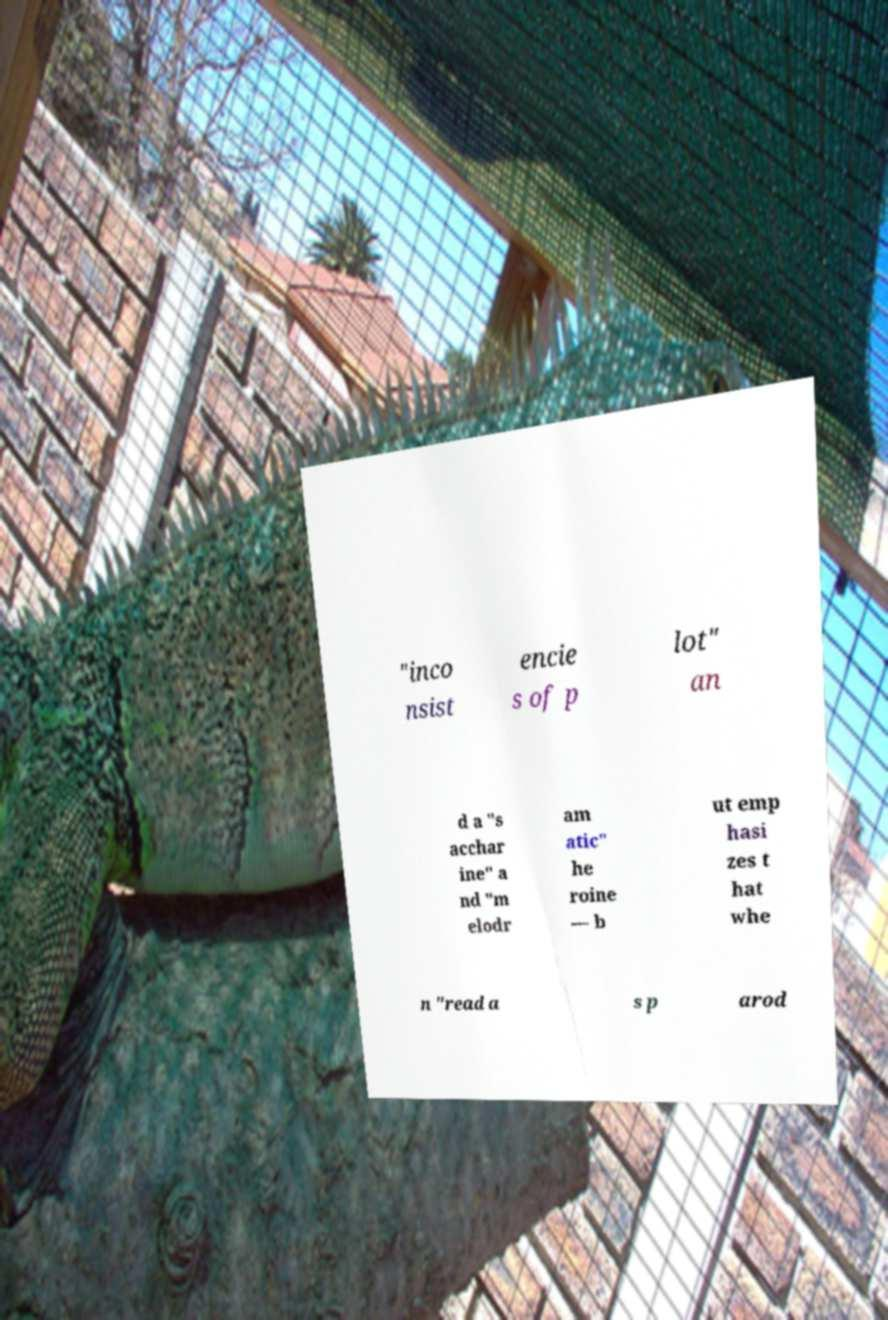Can you accurately transcribe the text from the provided image for me? "inco nsist encie s of p lot" an d a "s acchar ine" a nd "m elodr am atic" he roine — b ut emp hasi zes t hat whe n "read a s p arod 